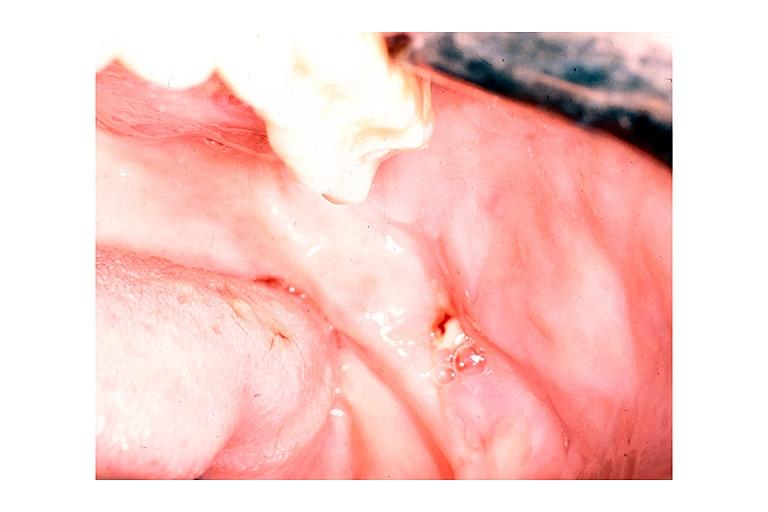what is present?
Answer the question using a single word or phrase. Oral 